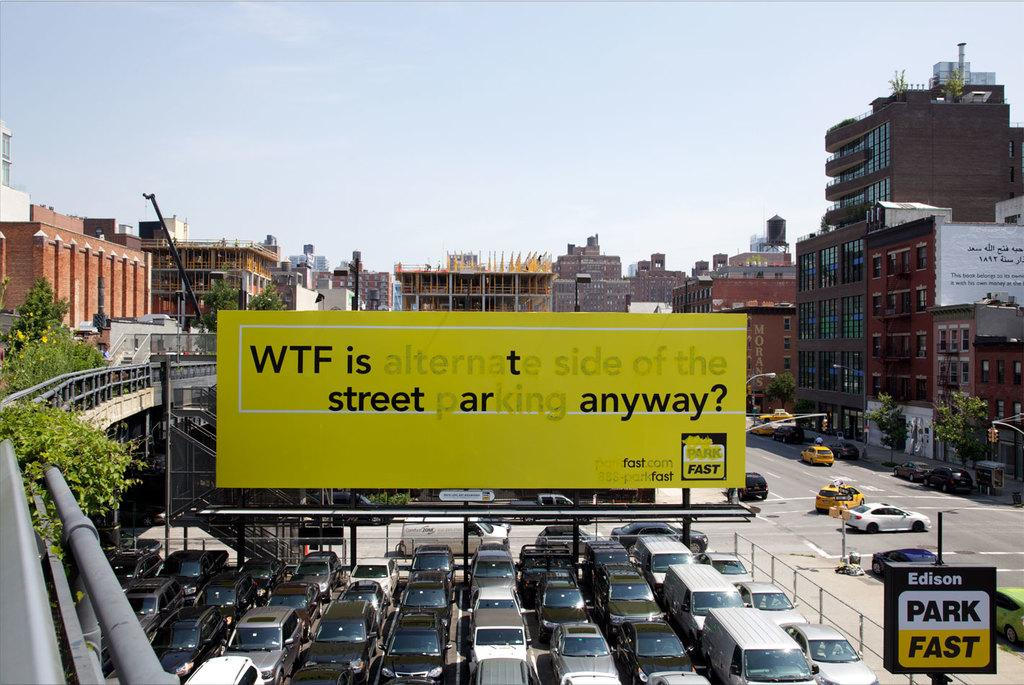<image>
Present a compact description of the photo's key features. Above multiple rows of cars that are bumper to bumper is a billboard sarcastically asking for the definition of  street parking on the alternate side of the street. 